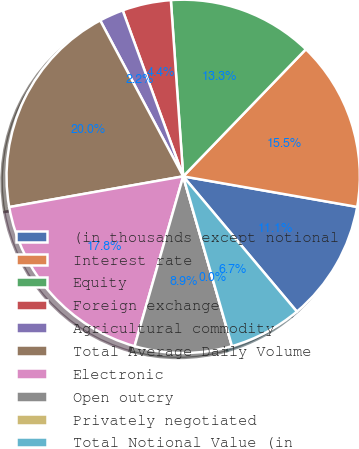Convert chart. <chart><loc_0><loc_0><loc_500><loc_500><pie_chart><fcel>(in thousands except notional<fcel>Interest rate<fcel>Equity<fcel>Foreign exchange<fcel>Agricultural commodity<fcel>Total Average Daily Volume<fcel>Electronic<fcel>Open outcry<fcel>Privately negotiated<fcel>Total Notional Value (in<nl><fcel>11.11%<fcel>15.55%<fcel>13.33%<fcel>4.45%<fcel>2.22%<fcel>20.0%<fcel>17.78%<fcel>8.89%<fcel>0.0%<fcel>6.67%<nl></chart> 